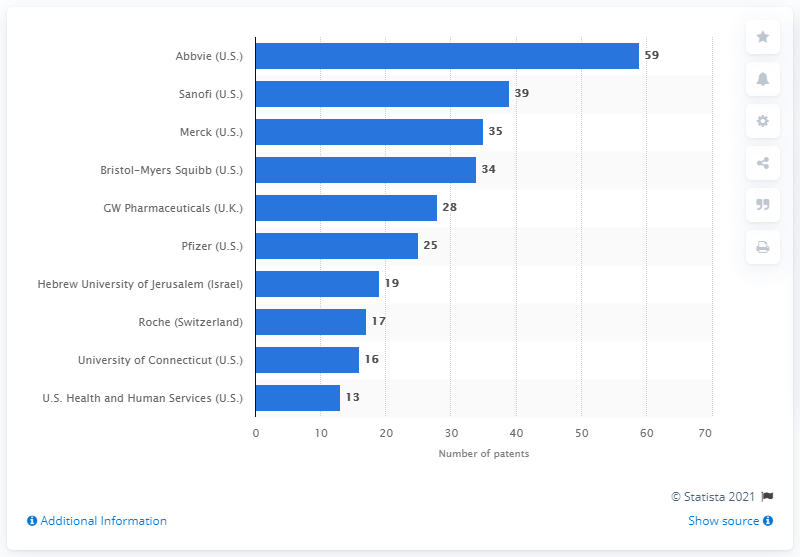List a handful of essential elements in this visual. In 2019, Sanofi obtained 39 patents. 